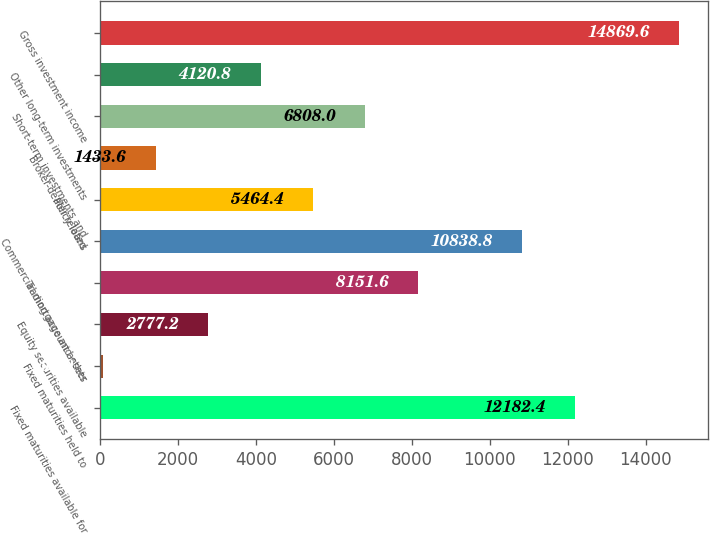<chart> <loc_0><loc_0><loc_500><loc_500><bar_chart><fcel>Fixed maturities available for<fcel>Fixed maturities held to<fcel>Equity securities available<fcel>Trading account assets<fcel>Commercial mortgage and other<fcel>Policy loans<fcel>Broker-dealer related<fcel>Short-term investments and<fcel>Other long-term investments<fcel>Gross investment income<nl><fcel>12182.4<fcel>90<fcel>2777.2<fcel>8151.6<fcel>10838.8<fcel>5464.4<fcel>1433.6<fcel>6808<fcel>4120.8<fcel>14869.6<nl></chart> 